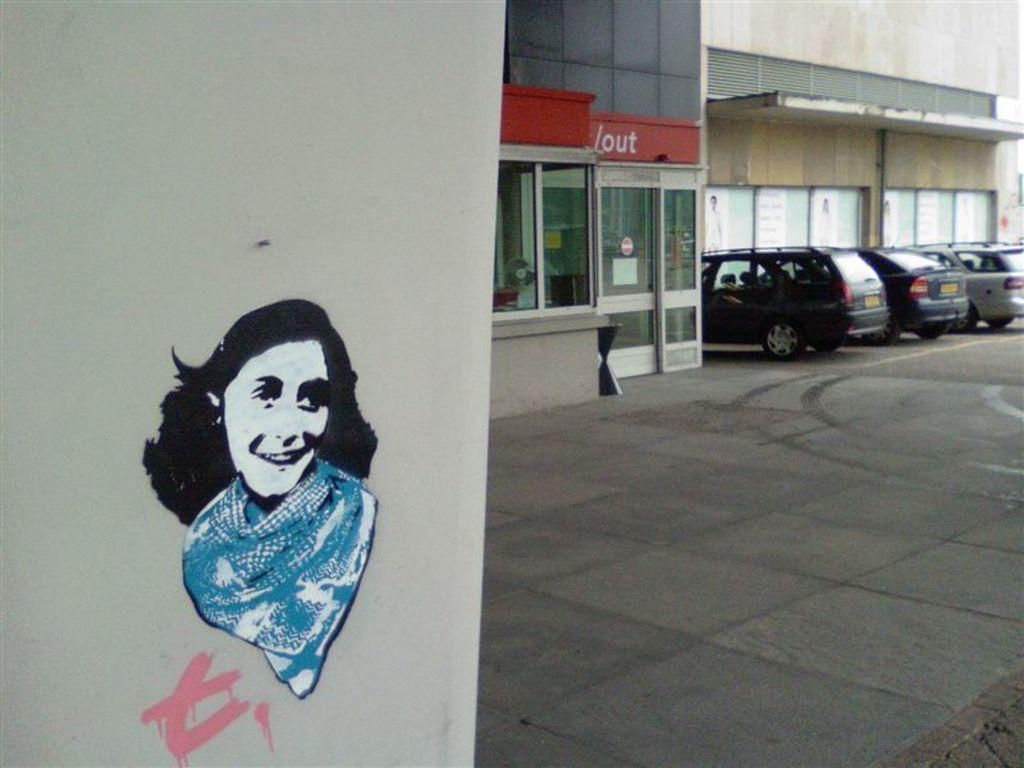What is displayed on the wall in the image? There is an art piece on the wall in the image. What can be seen in front of the building in the image? There are cars in front of the building in the image. How many roses are present in the image? There are no roses visible in the image. What type of liquid can be seen flowing from the art piece in the image? There is no liquid flowing from the art piece in the image; it is a stationary piece on the wall. 